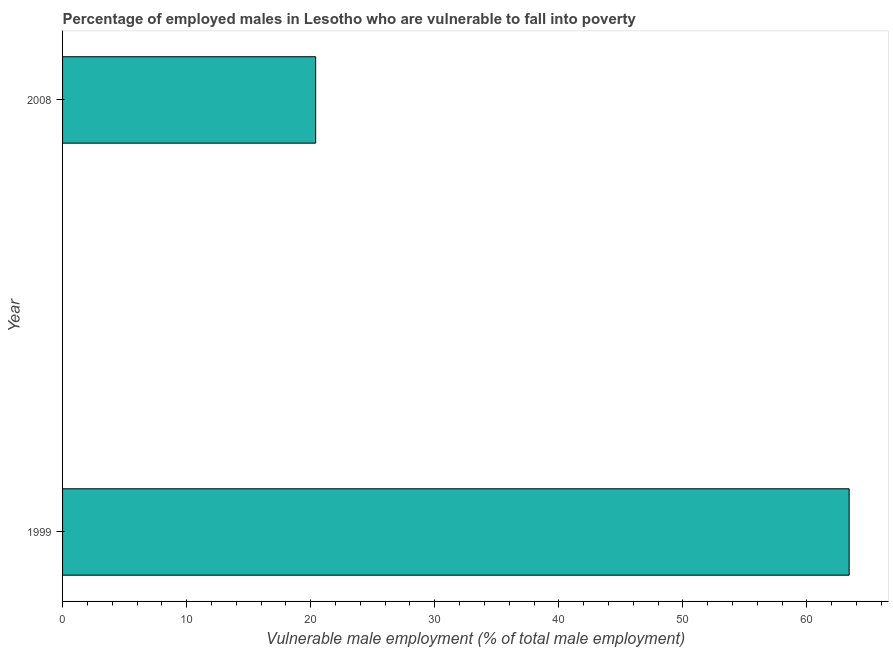Does the graph contain grids?
Offer a very short reply. No. What is the title of the graph?
Give a very brief answer. Percentage of employed males in Lesotho who are vulnerable to fall into poverty. What is the label or title of the X-axis?
Offer a terse response. Vulnerable male employment (% of total male employment). What is the label or title of the Y-axis?
Your answer should be very brief. Year. What is the percentage of employed males who are vulnerable to fall into poverty in 2008?
Make the answer very short. 20.4. Across all years, what is the maximum percentage of employed males who are vulnerable to fall into poverty?
Give a very brief answer. 63.4. Across all years, what is the minimum percentage of employed males who are vulnerable to fall into poverty?
Your answer should be very brief. 20.4. In which year was the percentage of employed males who are vulnerable to fall into poverty maximum?
Your answer should be very brief. 1999. What is the sum of the percentage of employed males who are vulnerable to fall into poverty?
Provide a succinct answer. 83.8. What is the difference between the percentage of employed males who are vulnerable to fall into poverty in 1999 and 2008?
Your answer should be compact. 43. What is the average percentage of employed males who are vulnerable to fall into poverty per year?
Your answer should be compact. 41.9. What is the median percentage of employed males who are vulnerable to fall into poverty?
Ensure brevity in your answer.  41.9. In how many years, is the percentage of employed males who are vulnerable to fall into poverty greater than 2 %?
Make the answer very short. 2. What is the ratio of the percentage of employed males who are vulnerable to fall into poverty in 1999 to that in 2008?
Make the answer very short. 3.11. How many bars are there?
Offer a very short reply. 2. Are all the bars in the graph horizontal?
Give a very brief answer. Yes. How many years are there in the graph?
Your answer should be compact. 2. Are the values on the major ticks of X-axis written in scientific E-notation?
Make the answer very short. No. What is the Vulnerable male employment (% of total male employment) of 1999?
Your response must be concise. 63.4. What is the Vulnerable male employment (% of total male employment) in 2008?
Your answer should be compact. 20.4. What is the ratio of the Vulnerable male employment (% of total male employment) in 1999 to that in 2008?
Provide a succinct answer. 3.11. 